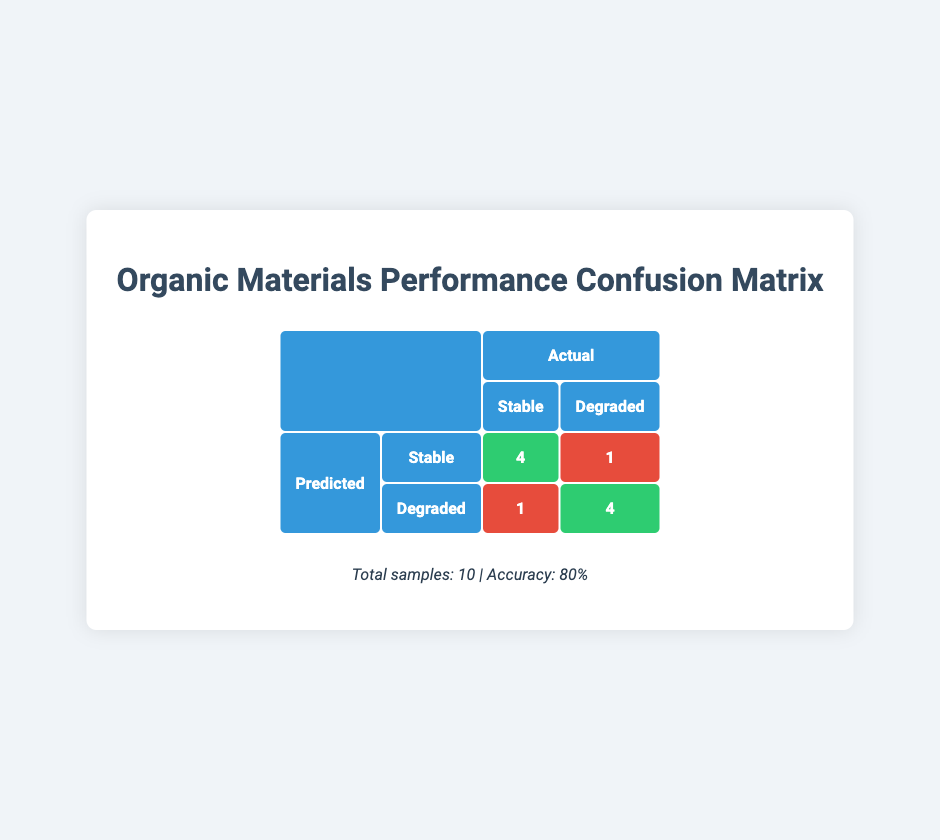What is the accuracy of the organic materials' performance in different conditions? The table indicates that the total number of samples is 10, and the accuracy is stated as 80%. Thus, the accuracy reflects the proportion of correct predictions out of the total samples.
Answer: 80% Which material showed a degraded prediction under high humidity? The table lists two predictions for 'Polylactic Acid (PLA)' under high humidity. One was accurately predicted as degraded, while the other predicted stable was incorrect. Thus, the material that predicted degraded is 'Polylactic Acid (PLA)'.
Answer: Polylactic Acid (PLA) How many materials predicted as stable were actually stable? From the table, we tally up the predicted stable situations. There are 4 instances where materials predicted as stable were indeed stable (Chitosan under neutral pH, Cellulose Acetate under indoor environment, and the stable predictions from Polyhydroxyalkanoates).
Answer: 4 Was there any case of a false negative in the predictions? A false negative occurs when a material that is actually stable is predicted to be degraded. Referring to the table, 'Starch-Based Biocomposites' is the only case where it was predicted to be degraded but was actually stable.
Answer: Yes Which environmental condition resulted in the most correct predictions? To find this, we assess each environmental condition's performance. The conditions of High Temperature, Low Temperature, Neutral pH, Acidic pH, and Indoor Environment effectively produced correct predictions. All were accurate (2 stable, 2 degraded). Hence, conditions like High Temperature and Low Temperature had 100% accuracy.
Answer: High Temperature and Low Temperature What is the number of predicted stable outcomes that were actually degraded? Referring to the table, only one instance exists where a material predicted stable was actually degraded, which is the case for 'Starch-Based Biocomposites' in the high moisture condition.
Answer: 1 Which condition has the highest number of incorrect predictions? Here, we examine the predictions for each condition. 'Starch-Based Biocomposites' under high moisture had an incorrect prediction, as did 'Polylactic Acid (PLA)' under high humidity. Thus, these conditions yielded the most incorrect predictions, leading to equal counts per condition.
Answer: High Moisture and High Humidity How many total samples predicted to be degraded were actually stable? Looking at the table, only one case was identified where a degradation prediction did not match the actual outcome: 'Starch-Based Biocomposites' under high moisture, which was stable. Thus, only one incorrect prediction exists in this context.
Answer: 1 